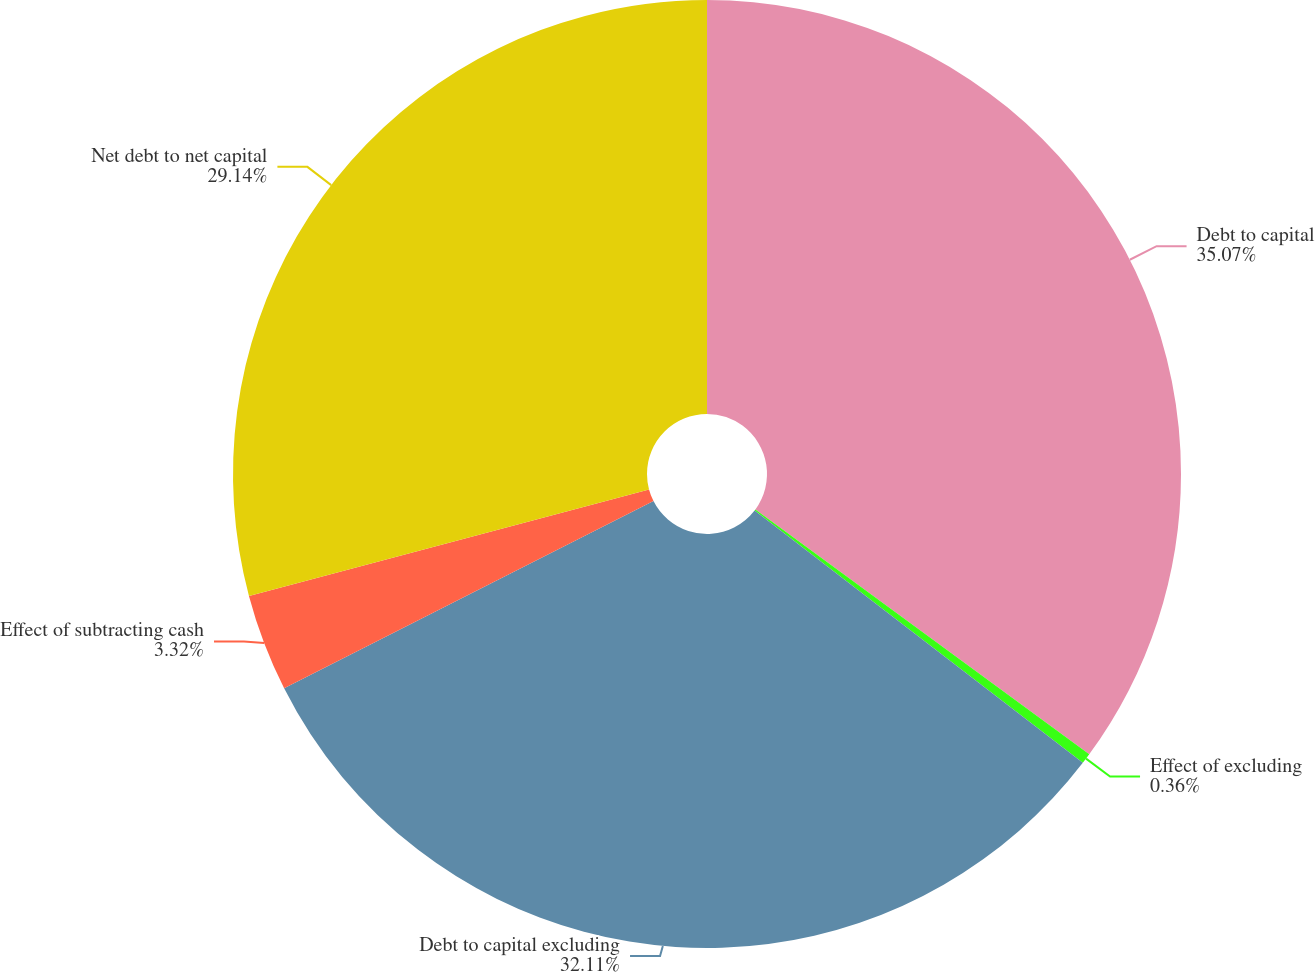Convert chart. <chart><loc_0><loc_0><loc_500><loc_500><pie_chart><fcel>Debt to capital<fcel>Effect of excluding<fcel>Debt to capital excluding<fcel>Effect of subtracting cash<fcel>Net debt to net capital<nl><fcel>35.07%<fcel>0.36%<fcel>32.11%<fcel>3.32%<fcel>29.14%<nl></chart> 